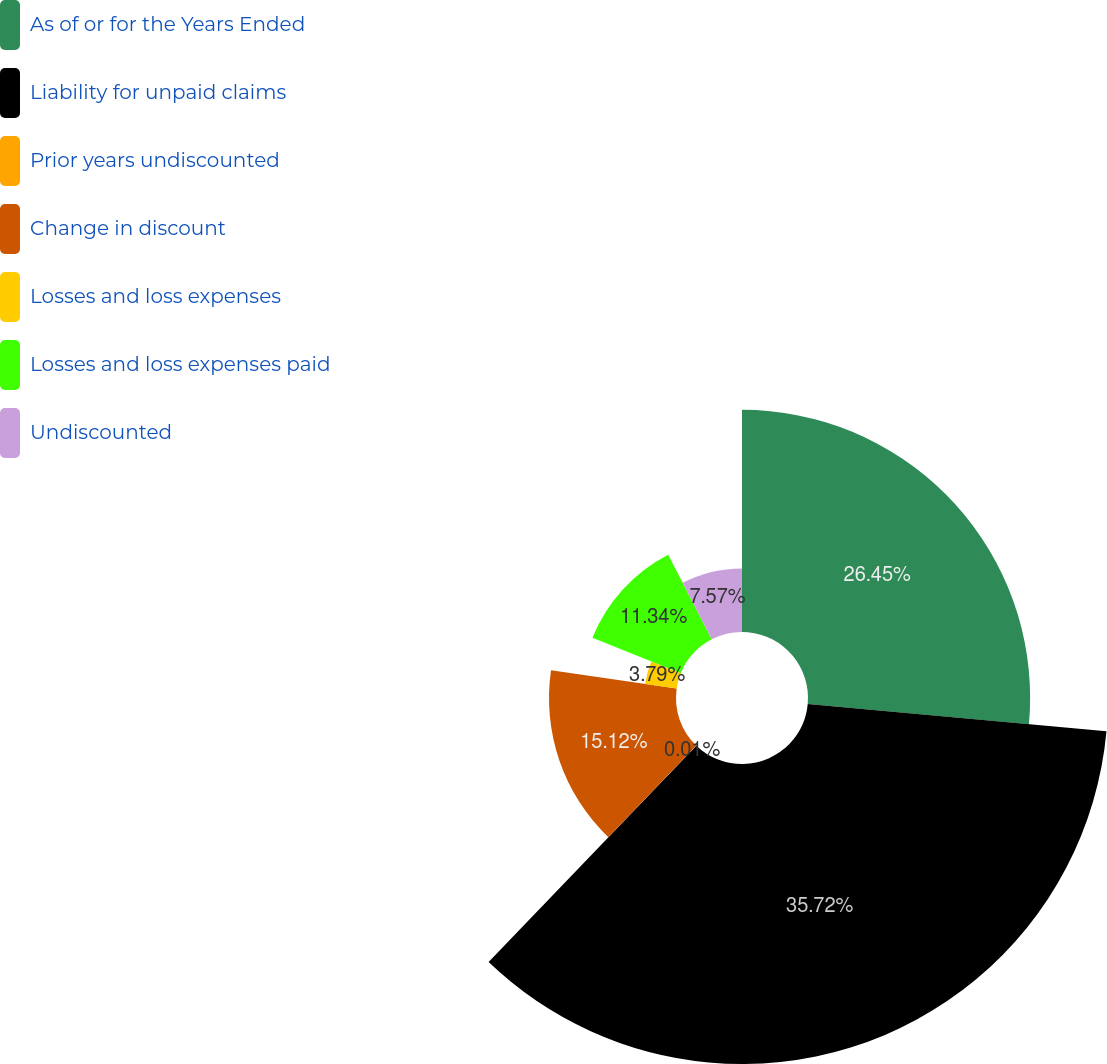Convert chart to OTSL. <chart><loc_0><loc_0><loc_500><loc_500><pie_chart><fcel>As of or for the Years Ended<fcel>Liability for unpaid claims<fcel>Prior years undiscounted<fcel>Change in discount<fcel>Losses and loss expenses<fcel>Losses and loss expenses paid<fcel>Undiscounted<nl><fcel>26.45%<fcel>35.72%<fcel>0.01%<fcel>15.12%<fcel>3.79%<fcel>11.34%<fcel>7.57%<nl></chart> 